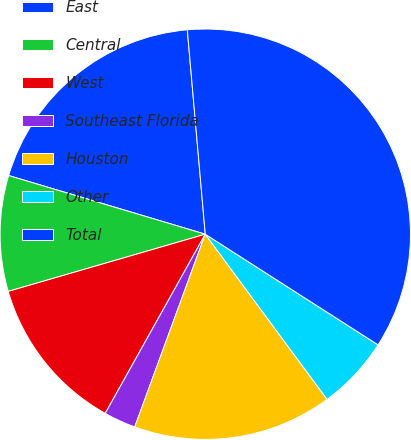<chart> <loc_0><loc_0><loc_500><loc_500><pie_chart><fcel>East<fcel>Central<fcel>West<fcel>Southeast Florida<fcel>Houston<fcel>Other<fcel>Total<nl><fcel>18.99%<fcel>9.11%<fcel>12.4%<fcel>2.52%<fcel>15.7%<fcel>5.82%<fcel>35.46%<nl></chart> 